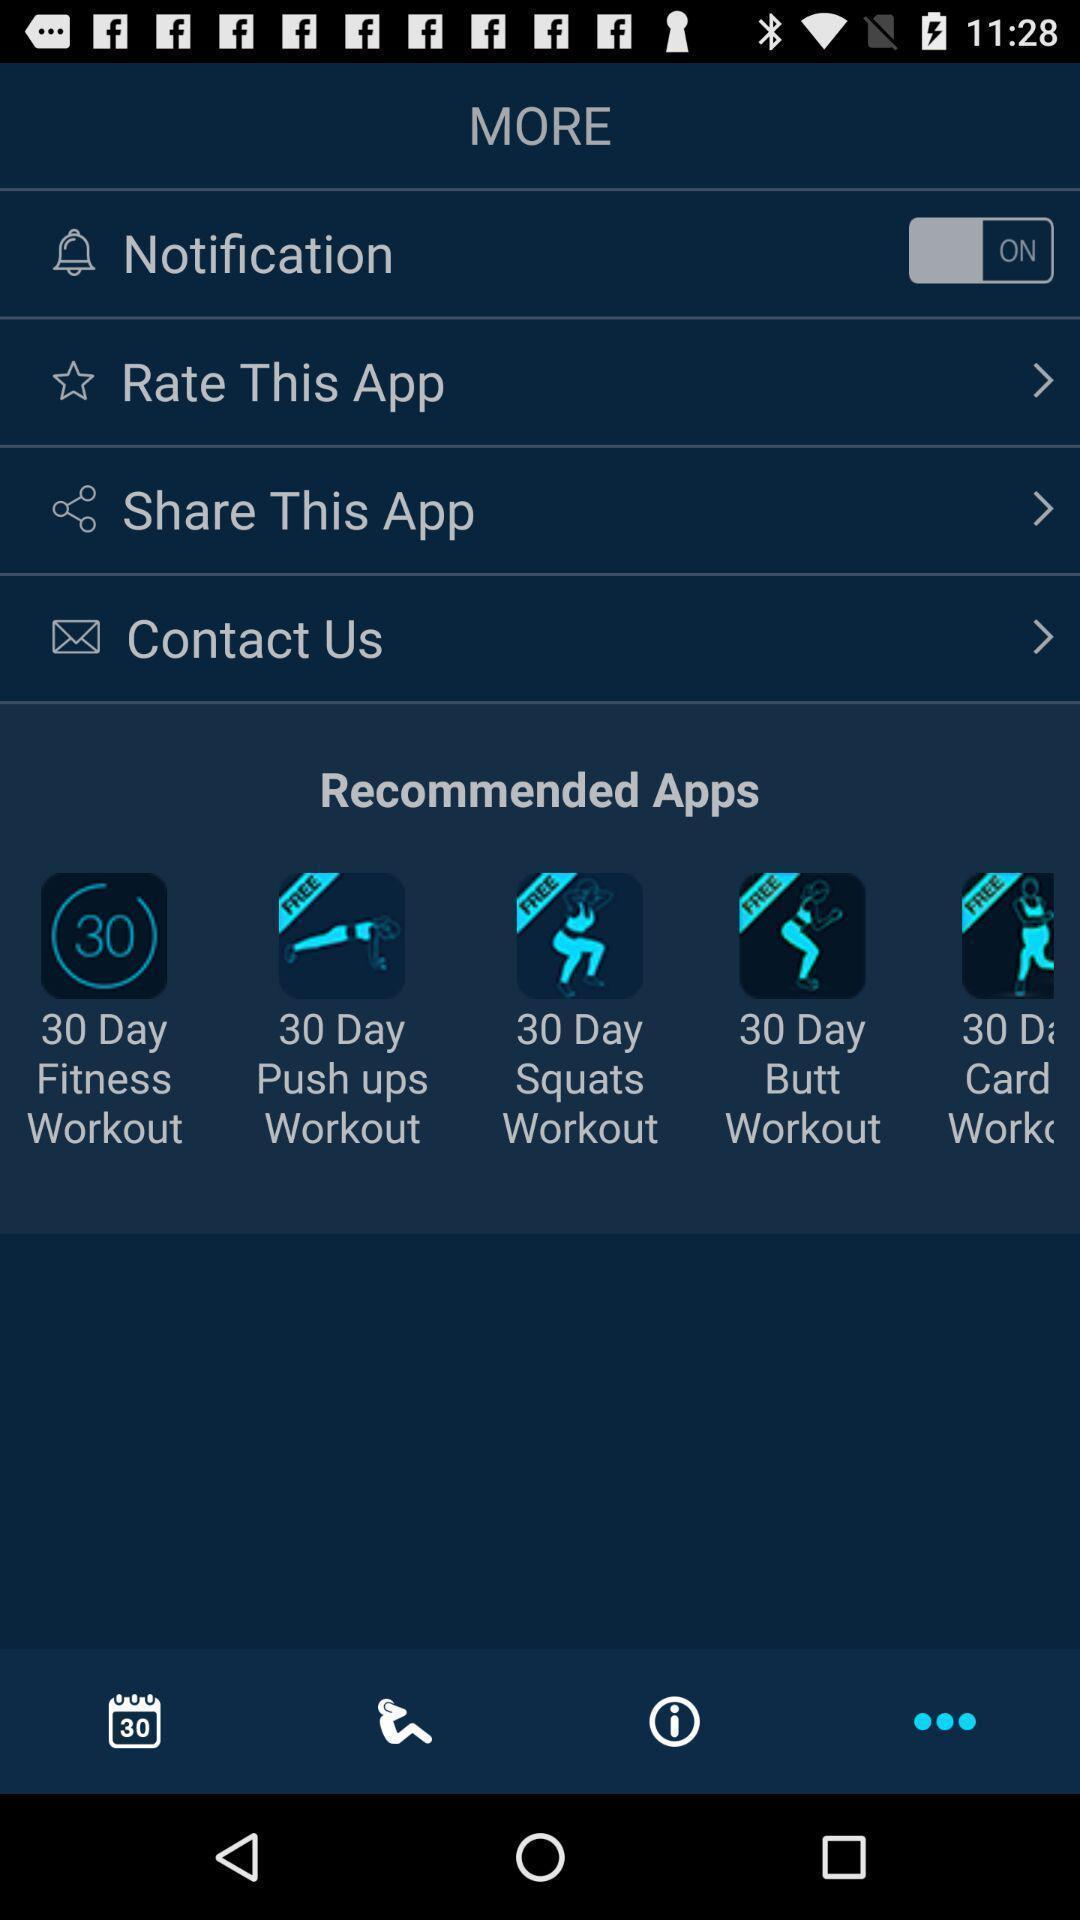Give me a summary of this screen capture. Screen displaying list of recommended app for exercise. 